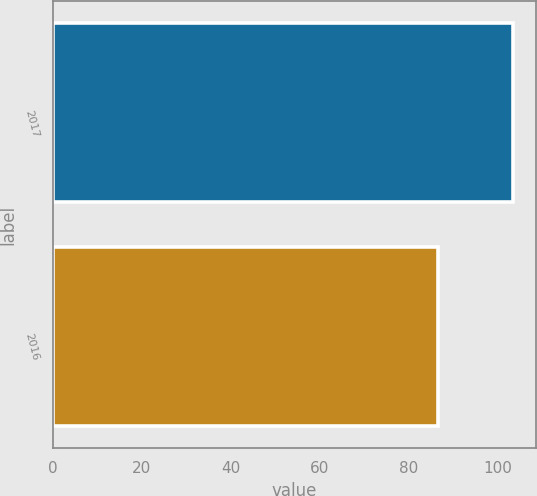Convert chart. <chart><loc_0><loc_0><loc_500><loc_500><bar_chart><fcel>2017<fcel>2016<nl><fcel>103.36<fcel>86.5<nl></chart> 